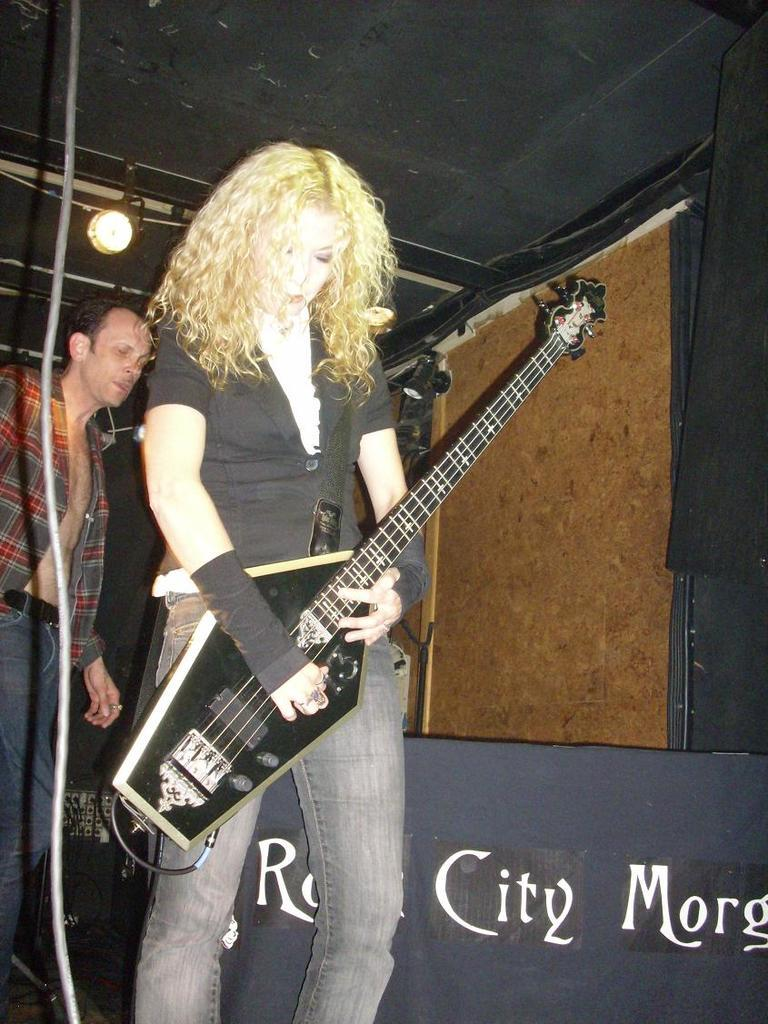What can be seen in the image that provides light? There is a light in the image. How many people are present in the image? There are two people in the image. Can you describe one of the people in the image? One of the people is a woman. What is the woman doing in the image? The woman is standing. What is the woman holding in the image? The woman is holding a guitar. What type of crime is being committed in the image? There is no crime being committed in the image; it features a woman standing and holding a guitar. Can you describe the cub that is present in the image? There is no cub present in the image. What type of truck can be seen in the image? There is no truck present in the image. 